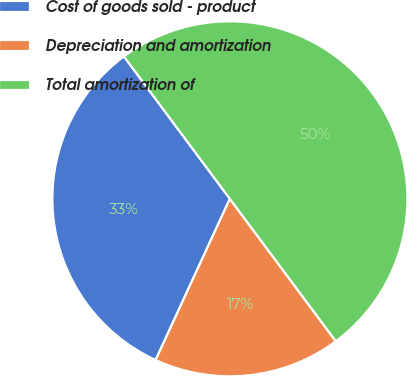<chart> <loc_0><loc_0><loc_500><loc_500><pie_chart><fcel>Cost of goods sold - product<fcel>Depreciation and amortization<fcel>Total amortization of<nl><fcel>32.95%<fcel>17.05%<fcel>50.0%<nl></chart> 